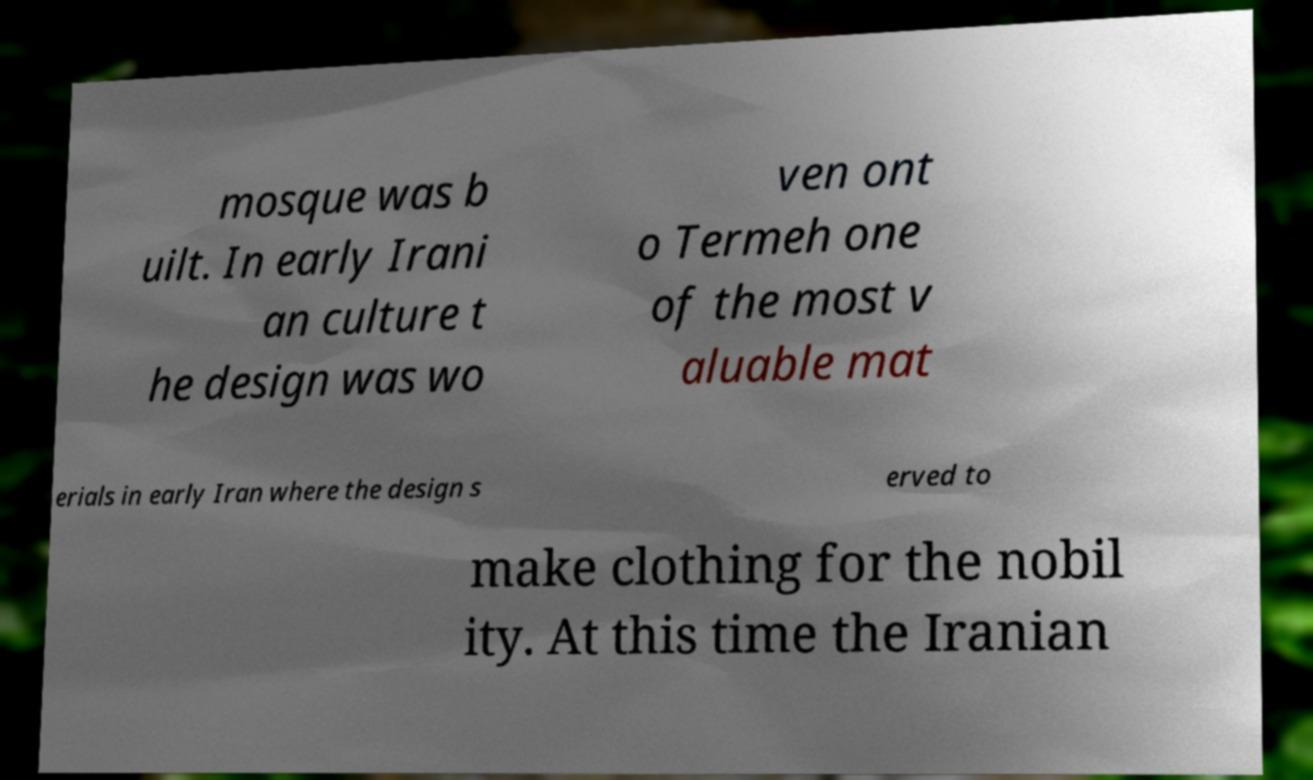Could you extract and type out the text from this image? mosque was b uilt. In early Irani an culture t he design was wo ven ont o Termeh one of the most v aluable mat erials in early Iran where the design s erved to make clothing for the nobil ity. At this time the Iranian 